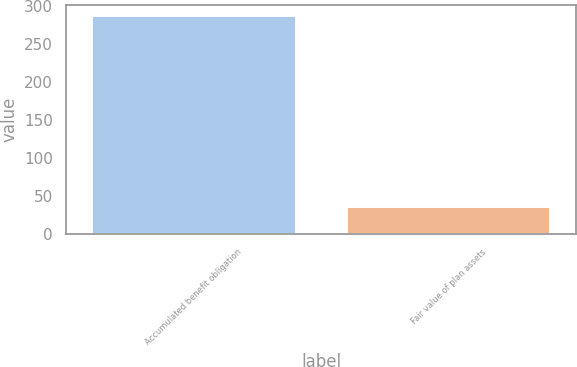Convert chart to OTSL. <chart><loc_0><loc_0><loc_500><loc_500><bar_chart><fcel>Accumulated benefit obligation<fcel>Fair value of plan assets<nl><fcel>287<fcel>36<nl></chart> 